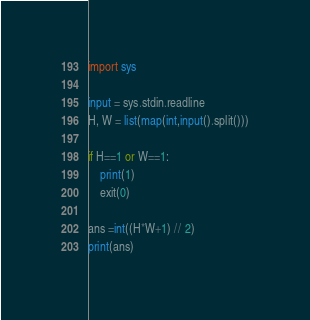Convert code to text. <code><loc_0><loc_0><loc_500><loc_500><_Python_>import sys
 
input = sys.stdin.readline
H, W = list(map(int,input().split()))
 
if H==1 or W==1:
    print(1)
    exit(0)

ans =int((H*W+1) // 2)
print(ans)</code> 